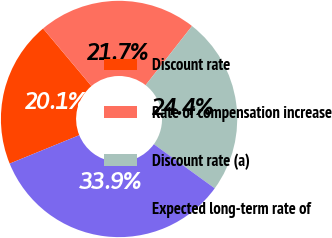Convert chart. <chart><loc_0><loc_0><loc_500><loc_500><pie_chart><fcel>Discount rate<fcel>Rate of compensation increase<fcel>Discount rate (a)<fcel>Expected long-term rate of<nl><fcel>20.05%<fcel>21.71%<fcel>24.39%<fcel>33.85%<nl></chart> 